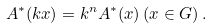Convert formula to latex. <formula><loc_0><loc_0><loc_500><loc_500>A ^ { \ast } ( k x ) = k ^ { n } A ^ { \ast } ( x ) \left ( x \in G \right ) .</formula> 